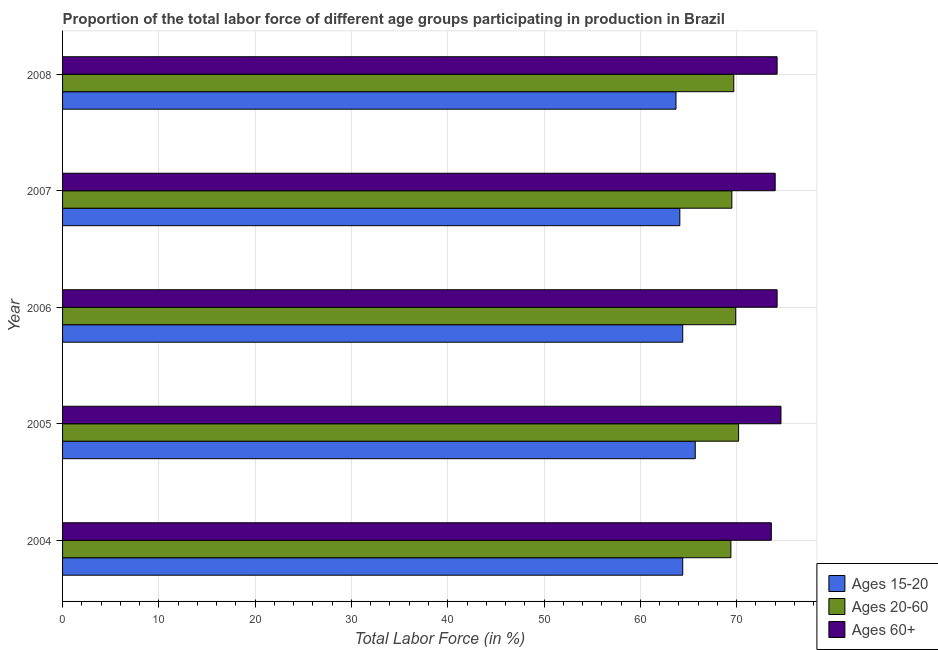How many groups of bars are there?
Provide a succinct answer. 5. Are the number of bars per tick equal to the number of legend labels?
Give a very brief answer. Yes. Are the number of bars on each tick of the Y-axis equal?
Your response must be concise. Yes. How many bars are there on the 5th tick from the top?
Your answer should be very brief. 3. How many bars are there on the 4th tick from the bottom?
Your response must be concise. 3. In how many cases, is the number of bars for a given year not equal to the number of legend labels?
Ensure brevity in your answer.  0. What is the percentage of labor force within the age group 15-20 in 2008?
Provide a succinct answer. 63.7. Across all years, what is the maximum percentage of labor force within the age group 15-20?
Offer a very short reply. 65.7. Across all years, what is the minimum percentage of labor force within the age group 20-60?
Provide a short and direct response. 69.4. In which year was the percentage of labor force within the age group 15-20 maximum?
Keep it short and to the point. 2005. What is the total percentage of labor force within the age group 15-20 in the graph?
Give a very brief answer. 322.3. What is the difference between the percentage of labor force above age 60 in 2007 and the percentage of labor force within the age group 20-60 in 2004?
Offer a very short reply. 4.6. What is the average percentage of labor force within the age group 15-20 per year?
Offer a terse response. 64.46. In the year 2004, what is the difference between the percentage of labor force within the age group 20-60 and percentage of labor force within the age group 15-20?
Your answer should be compact. 5. Is the difference between the percentage of labor force within the age group 15-20 in 2005 and 2007 greater than the difference between the percentage of labor force above age 60 in 2005 and 2007?
Ensure brevity in your answer.  Yes. What is the difference between the highest and the lowest percentage of labor force within the age group 20-60?
Offer a very short reply. 0.8. Is the sum of the percentage of labor force above age 60 in 2005 and 2006 greater than the maximum percentage of labor force within the age group 15-20 across all years?
Your answer should be very brief. Yes. What does the 1st bar from the top in 2008 represents?
Your answer should be very brief. Ages 60+. What does the 3rd bar from the bottom in 2008 represents?
Provide a succinct answer. Ages 60+. How many bars are there?
Your answer should be very brief. 15. Are all the bars in the graph horizontal?
Your answer should be compact. Yes. What is the difference between two consecutive major ticks on the X-axis?
Provide a succinct answer. 10. Are the values on the major ticks of X-axis written in scientific E-notation?
Make the answer very short. No. Does the graph contain grids?
Make the answer very short. Yes. Where does the legend appear in the graph?
Make the answer very short. Bottom right. How many legend labels are there?
Offer a very short reply. 3. How are the legend labels stacked?
Your response must be concise. Vertical. What is the title of the graph?
Keep it short and to the point. Proportion of the total labor force of different age groups participating in production in Brazil. What is the label or title of the Y-axis?
Make the answer very short. Year. What is the Total Labor Force (in %) of Ages 15-20 in 2004?
Offer a terse response. 64.4. What is the Total Labor Force (in %) in Ages 20-60 in 2004?
Provide a succinct answer. 69.4. What is the Total Labor Force (in %) in Ages 60+ in 2004?
Your answer should be very brief. 73.6. What is the Total Labor Force (in %) in Ages 15-20 in 2005?
Your answer should be very brief. 65.7. What is the Total Labor Force (in %) of Ages 20-60 in 2005?
Offer a terse response. 70.2. What is the Total Labor Force (in %) in Ages 60+ in 2005?
Your response must be concise. 74.6. What is the Total Labor Force (in %) in Ages 15-20 in 2006?
Give a very brief answer. 64.4. What is the Total Labor Force (in %) of Ages 20-60 in 2006?
Your response must be concise. 69.9. What is the Total Labor Force (in %) in Ages 60+ in 2006?
Your response must be concise. 74.2. What is the Total Labor Force (in %) of Ages 15-20 in 2007?
Your answer should be very brief. 64.1. What is the Total Labor Force (in %) of Ages 20-60 in 2007?
Your answer should be very brief. 69.5. What is the Total Labor Force (in %) of Ages 15-20 in 2008?
Keep it short and to the point. 63.7. What is the Total Labor Force (in %) in Ages 20-60 in 2008?
Make the answer very short. 69.7. What is the Total Labor Force (in %) of Ages 60+ in 2008?
Make the answer very short. 74.2. Across all years, what is the maximum Total Labor Force (in %) in Ages 15-20?
Keep it short and to the point. 65.7. Across all years, what is the maximum Total Labor Force (in %) in Ages 20-60?
Your answer should be very brief. 70.2. Across all years, what is the maximum Total Labor Force (in %) of Ages 60+?
Ensure brevity in your answer.  74.6. Across all years, what is the minimum Total Labor Force (in %) in Ages 15-20?
Your answer should be very brief. 63.7. Across all years, what is the minimum Total Labor Force (in %) of Ages 20-60?
Give a very brief answer. 69.4. Across all years, what is the minimum Total Labor Force (in %) of Ages 60+?
Ensure brevity in your answer.  73.6. What is the total Total Labor Force (in %) of Ages 15-20 in the graph?
Provide a succinct answer. 322.3. What is the total Total Labor Force (in %) of Ages 20-60 in the graph?
Keep it short and to the point. 348.7. What is the total Total Labor Force (in %) in Ages 60+ in the graph?
Make the answer very short. 370.6. What is the difference between the Total Labor Force (in %) of Ages 20-60 in 2004 and that in 2005?
Make the answer very short. -0.8. What is the difference between the Total Labor Force (in %) in Ages 15-20 in 2004 and that in 2006?
Make the answer very short. 0. What is the difference between the Total Labor Force (in %) in Ages 20-60 in 2004 and that in 2006?
Make the answer very short. -0.5. What is the difference between the Total Labor Force (in %) of Ages 15-20 in 2004 and that in 2007?
Provide a succinct answer. 0.3. What is the difference between the Total Labor Force (in %) in Ages 20-60 in 2004 and that in 2007?
Your answer should be very brief. -0.1. What is the difference between the Total Labor Force (in %) in Ages 60+ in 2004 and that in 2007?
Make the answer very short. -0.4. What is the difference between the Total Labor Force (in %) of Ages 20-60 in 2004 and that in 2008?
Your response must be concise. -0.3. What is the difference between the Total Labor Force (in %) of Ages 15-20 in 2005 and that in 2006?
Provide a succinct answer. 1.3. What is the difference between the Total Labor Force (in %) in Ages 60+ in 2005 and that in 2006?
Offer a very short reply. 0.4. What is the difference between the Total Labor Force (in %) of Ages 20-60 in 2005 and that in 2007?
Keep it short and to the point. 0.7. What is the difference between the Total Labor Force (in %) in Ages 15-20 in 2005 and that in 2008?
Ensure brevity in your answer.  2. What is the difference between the Total Labor Force (in %) of Ages 20-60 in 2005 and that in 2008?
Provide a short and direct response. 0.5. What is the difference between the Total Labor Force (in %) of Ages 60+ in 2005 and that in 2008?
Provide a short and direct response. 0.4. What is the difference between the Total Labor Force (in %) in Ages 15-20 in 2006 and that in 2007?
Provide a succinct answer. 0.3. What is the difference between the Total Labor Force (in %) of Ages 20-60 in 2006 and that in 2007?
Provide a succinct answer. 0.4. What is the difference between the Total Labor Force (in %) of Ages 60+ in 2006 and that in 2007?
Provide a short and direct response. 0.2. What is the difference between the Total Labor Force (in %) of Ages 20-60 in 2006 and that in 2008?
Your answer should be compact. 0.2. What is the difference between the Total Labor Force (in %) in Ages 60+ in 2007 and that in 2008?
Your answer should be very brief. -0.2. What is the difference between the Total Labor Force (in %) in Ages 15-20 in 2004 and the Total Labor Force (in %) in Ages 20-60 in 2005?
Provide a short and direct response. -5.8. What is the difference between the Total Labor Force (in %) of Ages 20-60 in 2004 and the Total Labor Force (in %) of Ages 60+ in 2005?
Offer a terse response. -5.2. What is the difference between the Total Labor Force (in %) of Ages 15-20 in 2004 and the Total Labor Force (in %) of Ages 20-60 in 2006?
Ensure brevity in your answer.  -5.5. What is the difference between the Total Labor Force (in %) of Ages 15-20 in 2004 and the Total Labor Force (in %) of Ages 60+ in 2006?
Give a very brief answer. -9.8. What is the difference between the Total Labor Force (in %) of Ages 20-60 in 2004 and the Total Labor Force (in %) of Ages 60+ in 2006?
Offer a terse response. -4.8. What is the difference between the Total Labor Force (in %) in Ages 20-60 in 2004 and the Total Labor Force (in %) in Ages 60+ in 2007?
Give a very brief answer. -4.6. What is the difference between the Total Labor Force (in %) in Ages 15-20 in 2004 and the Total Labor Force (in %) in Ages 20-60 in 2008?
Your answer should be very brief. -5.3. What is the difference between the Total Labor Force (in %) of Ages 15-20 in 2004 and the Total Labor Force (in %) of Ages 60+ in 2008?
Keep it short and to the point. -9.8. What is the difference between the Total Labor Force (in %) in Ages 20-60 in 2005 and the Total Labor Force (in %) in Ages 60+ in 2006?
Keep it short and to the point. -4. What is the difference between the Total Labor Force (in %) in Ages 15-20 in 2005 and the Total Labor Force (in %) in Ages 60+ in 2007?
Your answer should be very brief. -8.3. What is the difference between the Total Labor Force (in %) in Ages 20-60 in 2005 and the Total Labor Force (in %) in Ages 60+ in 2007?
Provide a short and direct response. -3.8. What is the difference between the Total Labor Force (in %) in Ages 15-20 in 2005 and the Total Labor Force (in %) in Ages 20-60 in 2008?
Offer a terse response. -4. What is the difference between the Total Labor Force (in %) of Ages 15-20 in 2006 and the Total Labor Force (in %) of Ages 60+ in 2007?
Your answer should be very brief. -9.6. What is the difference between the Total Labor Force (in %) of Ages 15-20 in 2006 and the Total Labor Force (in %) of Ages 20-60 in 2008?
Your answer should be compact. -5.3. What is the difference between the Total Labor Force (in %) of Ages 15-20 in 2006 and the Total Labor Force (in %) of Ages 60+ in 2008?
Provide a short and direct response. -9.8. What is the difference between the Total Labor Force (in %) of Ages 15-20 in 2007 and the Total Labor Force (in %) of Ages 20-60 in 2008?
Provide a short and direct response. -5.6. What is the difference between the Total Labor Force (in %) of Ages 15-20 in 2007 and the Total Labor Force (in %) of Ages 60+ in 2008?
Keep it short and to the point. -10.1. What is the difference between the Total Labor Force (in %) in Ages 20-60 in 2007 and the Total Labor Force (in %) in Ages 60+ in 2008?
Give a very brief answer. -4.7. What is the average Total Labor Force (in %) of Ages 15-20 per year?
Offer a very short reply. 64.46. What is the average Total Labor Force (in %) in Ages 20-60 per year?
Keep it short and to the point. 69.74. What is the average Total Labor Force (in %) of Ages 60+ per year?
Your response must be concise. 74.12. In the year 2004, what is the difference between the Total Labor Force (in %) of Ages 15-20 and Total Labor Force (in %) of Ages 60+?
Your answer should be very brief. -9.2. In the year 2006, what is the difference between the Total Labor Force (in %) of Ages 15-20 and Total Labor Force (in %) of Ages 20-60?
Your answer should be compact. -5.5. In the year 2006, what is the difference between the Total Labor Force (in %) in Ages 15-20 and Total Labor Force (in %) in Ages 60+?
Offer a very short reply. -9.8. In the year 2006, what is the difference between the Total Labor Force (in %) of Ages 20-60 and Total Labor Force (in %) of Ages 60+?
Your answer should be very brief. -4.3. In the year 2007, what is the difference between the Total Labor Force (in %) of Ages 15-20 and Total Labor Force (in %) of Ages 20-60?
Ensure brevity in your answer.  -5.4. In the year 2007, what is the difference between the Total Labor Force (in %) in Ages 20-60 and Total Labor Force (in %) in Ages 60+?
Keep it short and to the point. -4.5. In the year 2008, what is the difference between the Total Labor Force (in %) in Ages 15-20 and Total Labor Force (in %) in Ages 60+?
Provide a succinct answer. -10.5. What is the ratio of the Total Labor Force (in %) in Ages 15-20 in 2004 to that in 2005?
Your answer should be very brief. 0.98. What is the ratio of the Total Labor Force (in %) of Ages 20-60 in 2004 to that in 2005?
Your answer should be very brief. 0.99. What is the ratio of the Total Labor Force (in %) of Ages 60+ in 2004 to that in 2005?
Your answer should be very brief. 0.99. What is the ratio of the Total Labor Force (in %) in Ages 60+ in 2004 to that in 2006?
Make the answer very short. 0.99. What is the ratio of the Total Labor Force (in %) in Ages 20-60 in 2004 to that in 2007?
Your answer should be compact. 1. What is the ratio of the Total Labor Force (in %) in Ages 60+ in 2004 to that in 2007?
Give a very brief answer. 0.99. What is the ratio of the Total Labor Force (in %) in Ages 15-20 in 2004 to that in 2008?
Your answer should be very brief. 1.01. What is the ratio of the Total Labor Force (in %) of Ages 20-60 in 2004 to that in 2008?
Offer a very short reply. 1. What is the ratio of the Total Labor Force (in %) in Ages 60+ in 2004 to that in 2008?
Your answer should be compact. 0.99. What is the ratio of the Total Labor Force (in %) of Ages 15-20 in 2005 to that in 2006?
Your response must be concise. 1.02. What is the ratio of the Total Labor Force (in %) in Ages 60+ in 2005 to that in 2006?
Offer a terse response. 1.01. What is the ratio of the Total Labor Force (in %) of Ages 15-20 in 2005 to that in 2008?
Give a very brief answer. 1.03. What is the ratio of the Total Labor Force (in %) of Ages 20-60 in 2005 to that in 2008?
Keep it short and to the point. 1.01. What is the ratio of the Total Labor Force (in %) of Ages 60+ in 2005 to that in 2008?
Provide a succinct answer. 1.01. What is the ratio of the Total Labor Force (in %) in Ages 20-60 in 2006 to that in 2007?
Keep it short and to the point. 1.01. What is the ratio of the Total Labor Force (in %) of Ages 60+ in 2006 to that in 2007?
Keep it short and to the point. 1. What is the ratio of the Total Labor Force (in %) in Ages 15-20 in 2006 to that in 2008?
Make the answer very short. 1.01. What is the ratio of the Total Labor Force (in %) in Ages 20-60 in 2006 to that in 2008?
Provide a short and direct response. 1. What is the ratio of the Total Labor Force (in %) of Ages 15-20 in 2007 to that in 2008?
Keep it short and to the point. 1.01. What is the ratio of the Total Labor Force (in %) of Ages 20-60 in 2007 to that in 2008?
Offer a very short reply. 1. What is the ratio of the Total Labor Force (in %) in Ages 60+ in 2007 to that in 2008?
Your response must be concise. 1. What is the difference between the highest and the lowest Total Labor Force (in %) in Ages 15-20?
Provide a succinct answer. 2. What is the difference between the highest and the lowest Total Labor Force (in %) of Ages 60+?
Keep it short and to the point. 1. 